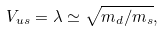<formula> <loc_0><loc_0><loc_500><loc_500>V _ { u s } = \lambda \simeq \sqrt { m _ { d } / m _ { s } } ,</formula> 